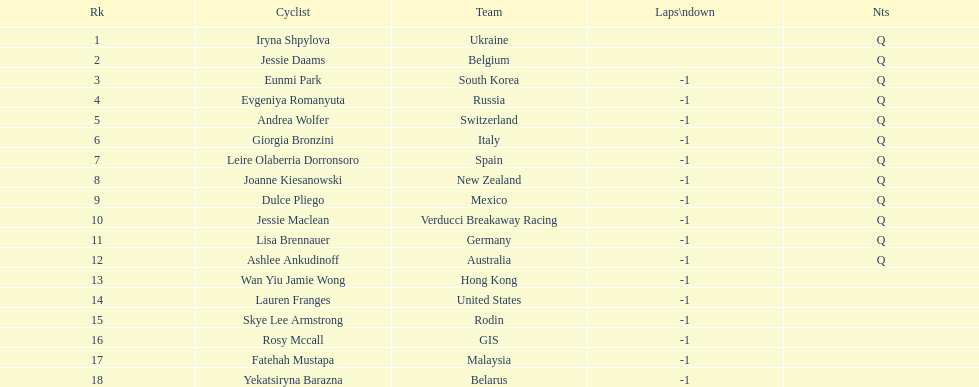Who was the leading contender in this race? Iryna Shpylova. 